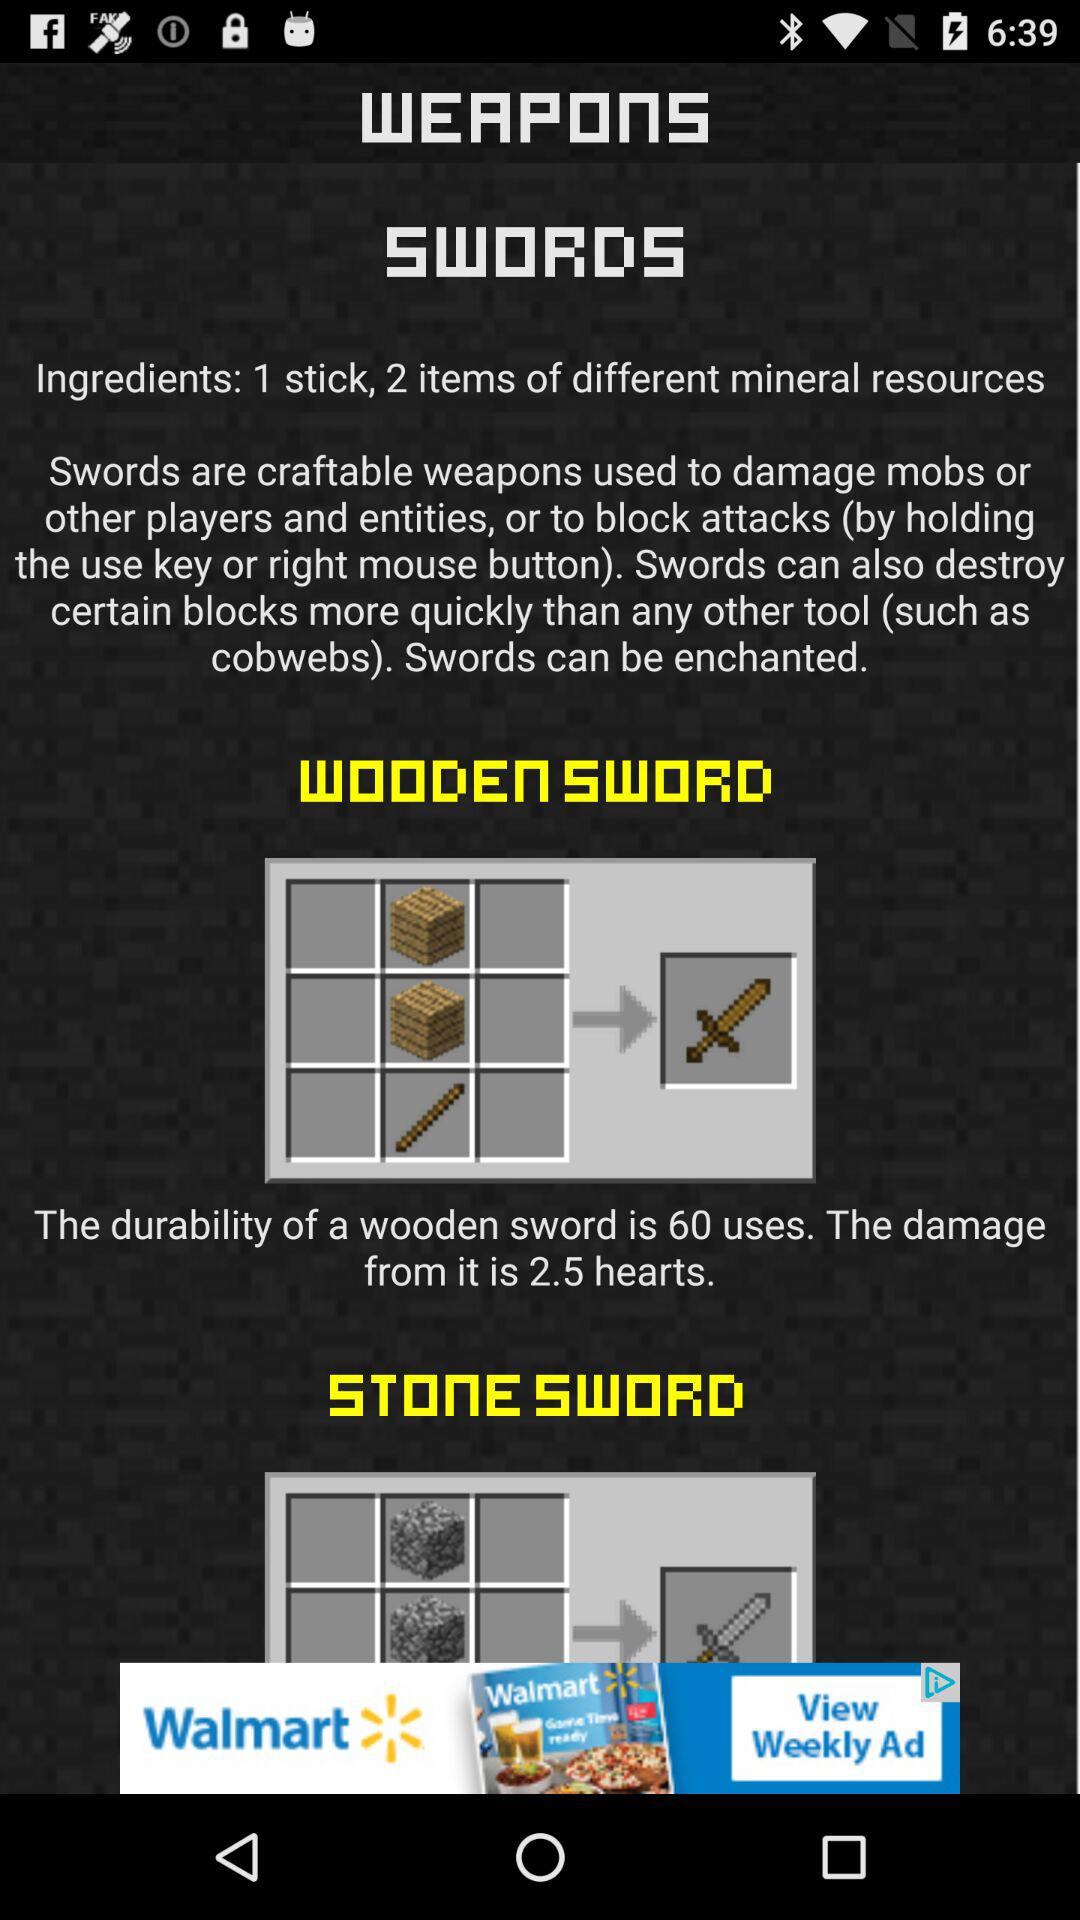What is the durability of the wooden sword? The durability is 60 uses. 